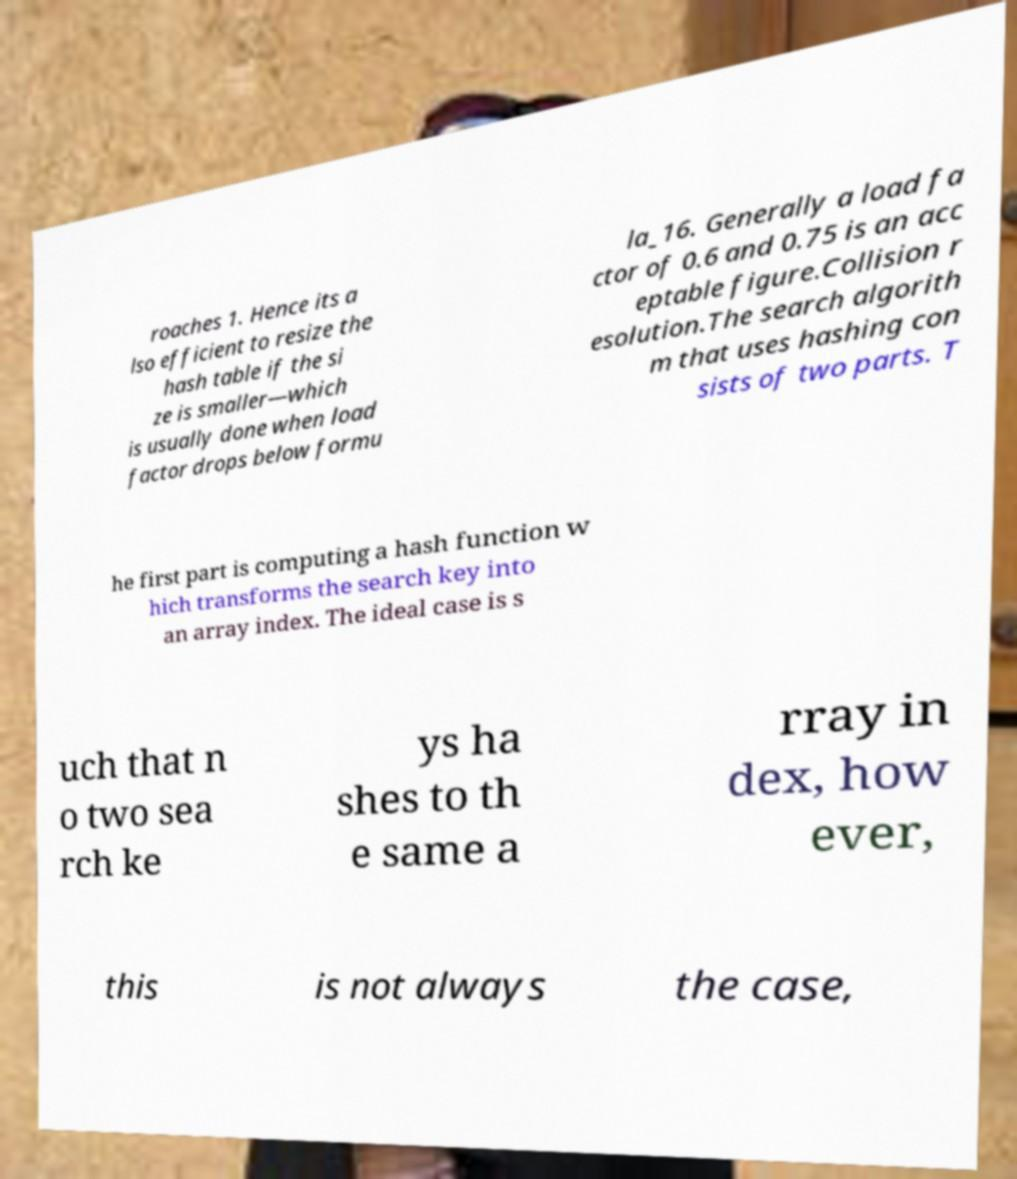Please read and relay the text visible in this image. What does it say? roaches 1. Hence its a lso efficient to resize the hash table if the si ze is smaller—which is usually done when load factor drops below formu la_16. Generally a load fa ctor of 0.6 and 0.75 is an acc eptable figure.Collision r esolution.The search algorith m that uses hashing con sists of two parts. T he first part is computing a hash function w hich transforms the search key into an array index. The ideal case is s uch that n o two sea rch ke ys ha shes to th e same a rray in dex, how ever, this is not always the case, 